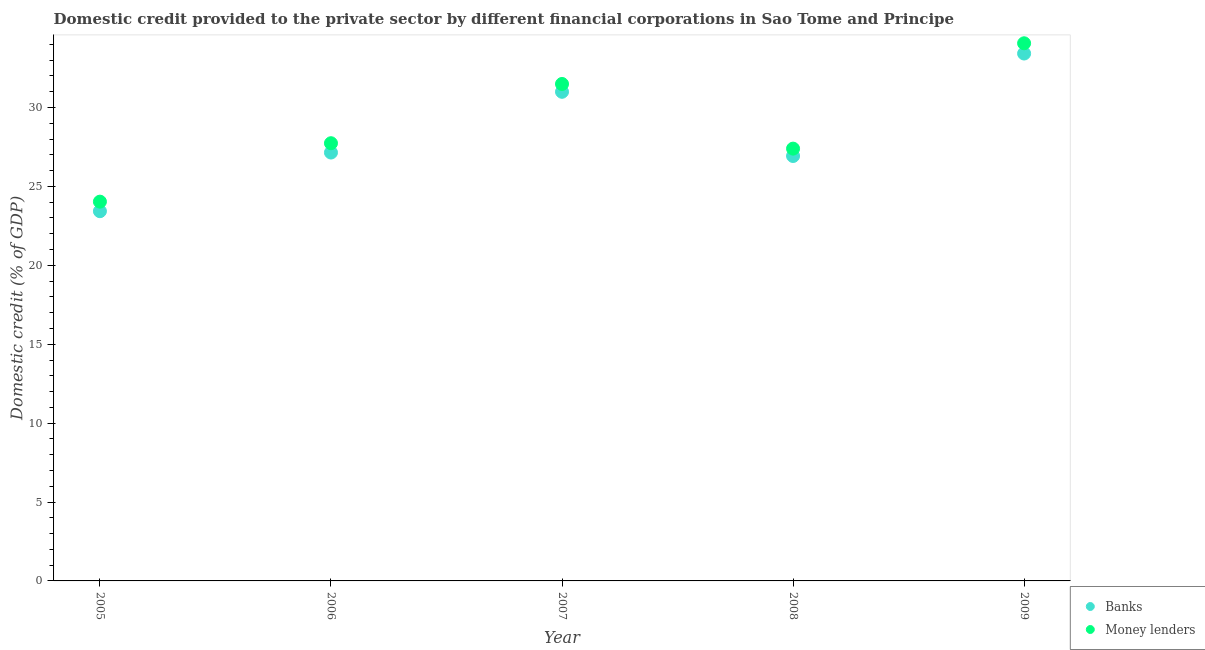How many different coloured dotlines are there?
Provide a short and direct response. 2. Is the number of dotlines equal to the number of legend labels?
Your response must be concise. Yes. What is the domestic credit provided by banks in 2008?
Your answer should be compact. 26.93. Across all years, what is the maximum domestic credit provided by banks?
Give a very brief answer. 33.42. Across all years, what is the minimum domestic credit provided by banks?
Your answer should be very brief. 23.43. What is the total domestic credit provided by banks in the graph?
Your response must be concise. 141.93. What is the difference between the domestic credit provided by money lenders in 2005 and that in 2007?
Provide a succinct answer. -7.46. What is the difference between the domestic credit provided by banks in 2007 and the domestic credit provided by money lenders in 2005?
Offer a very short reply. 6.96. What is the average domestic credit provided by banks per year?
Your response must be concise. 28.39. In the year 2006, what is the difference between the domestic credit provided by banks and domestic credit provided by money lenders?
Your answer should be compact. -0.59. What is the ratio of the domestic credit provided by banks in 2005 to that in 2007?
Your answer should be compact. 0.76. Is the domestic credit provided by money lenders in 2006 less than that in 2008?
Your response must be concise. No. What is the difference between the highest and the second highest domestic credit provided by banks?
Give a very brief answer. 2.43. What is the difference between the highest and the lowest domestic credit provided by banks?
Provide a short and direct response. 9.99. In how many years, is the domestic credit provided by money lenders greater than the average domestic credit provided by money lenders taken over all years?
Give a very brief answer. 2. Does the domestic credit provided by banks monotonically increase over the years?
Keep it short and to the point. No. What is the difference between two consecutive major ticks on the Y-axis?
Offer a very short reply. 5. Are the values on the major ticks of Y-axis written in scientific E-notation?
Your answer should be very brief. No. Does the graph contain grids?
Give a very brief answer. No. How many legend labels are there?
Provide a succinct answer. 2. What is the title of the graph?
Your answer should be compact. Domestic credit provided to the private sector by different financial corporations in Sao Tome and Principe. Does "Central government" appear as one of the legend labels in the graph?
Keep it short and to the point. No. What is the label or title of the X-axis?
Provide a short and direct response. Year. What is the label or title of the Y-axis?
Offer a terse response. Domestic credit (% of GDP). What is the Domestic credit (% of GDP) in Banks in 2005?
Make the answer very short. 23.43. What is the Domestic credit (% of GDP) in Money lenders in 2005?
Your response must be concise. 24.04. What is the Domestic credit (% of GDP) of Banks in 2006?
Your answer should be compact. 27.15. What is the Domestic credit (% of GDP) of Money lenders in 2006?
Make the answer very short. 27.74. What is the Domestic credit (% of GDP) in Banks in 2007?
Keep it short and to the point. 31. What is the Domestic credit (% of GDP) in Money lenders in 2007?
Provide a succinct answer. 31.49. What is the Domestic credit (% of GDP) in Banks in 2008?
Offer a very short reply. 26.93. What is the Domestic credit (% of GDP) in Money lenders in 2008?
Provide a succinct answer. 27.4. What is the Domestic credit (% of GDP) of Banks in 2009?
Your answer should be very brief. 33.42. What is the Domestic credit (% of GDP) in Money lenders in 2009?
Ensure brevity in your answer.  34.07. Across all years, what is the maximum Domestic credit (% of GDP) of Banks?
Your answer should be compact. 33.42. Across all years, what is the maximum Domestic credit (% of GDP) in Money lenders?
Make the answer very short. 34.07. Across all years, what is the minimum Domestic credit (% of GDP) of Banks?
Keep it short and to the point. 23.43. Across all years, what is the minimum Domestic credit (% of GDP) of Money lenders?
Give a very brief answer. 24.04. What is the total Domestic credit (% of GDP) of Banks in the graph?
Offer a very short reply. 141.93. What is the total Domestic credit (% of GDP) of Money lenders in the graph?
Provide a succinct answer. 144.74. What is the difference between the Domestic credit (% of GDP) of Banks in 2005 and that in 2006?
Provide a succinct answer. -3.72. What is the difference between the Domestic credit (% of GDP) in Money lenders in 2005 and that in 2006?
Provide a short and direct response. -3.7. What is the difference between the Domestic credit (% of GDP) in Banks in 2005 and that in 2007?
Provide a succinct answer. -7.57. What is the difference between the Domestic credit (% of GDP) of Money lenders in 2005 and that in 2007?
Offer a very short reply. -7.46. What is the difference between the Domestic credit (% of GDP) in Banks in 2005 and that in 2008?
Keep it short and to the point. -3.5. What is the difference between the Domestic credit (% of GDP) of Money lenders in 2005 and that in 2008?
Ensure brevity in your answer.  -3.36. What is the difference between the Domestic credit (% of GDP) of Banks in 2005 and that in 2009?
Your answer should be compact. -9.99. What is the difference between the Domestic credit (% of GDP) in Money lenders in 2005 and that in 2009?
Give a very brief answer. -10.04. What is the difference between the Domestic credit (% of GDP) of Banks in 2006 and that in 2007?
Your answer should be compact. -3.85. What is the difference between the Domestic credit (% of GDP) of Money lenders in 2006 and that in 2007?
Offer a very short reply. -3.75. What is the difference between the Domestic credit (% of GDP) of Banks in 2006 and that in 2008?
Your answer should be compact. 0.22. What is the difference between the Domestic credit (% of GDP) in Money lenders in 2006 and that in 2008?
Make the answer very short. 0.34. What is the difference between the Domestic credit (% of GDP) in Banks in 2006 and that in 2009?
Make the answer very short. -6.27. What is the difference between the Domestic credit (% of GDP) in Money lenders in 2006 and that in 2009?
Provide a short and direct response. -6.33. What is the difference between the Domestic credit (% of GDP) in Banks in 2007 and that in 2008?
Provide a succinct answer. 4.07. What is the difference between the Domestic credit (% of GDP) in Money lenders in 2007 and that in 2008?
Offer a terse response. 4.1. What is the difference between the Domestic credit (% of GDP) of Banks in 2007 and that in 2009?
Ensure brevity in your answer.  -2.43. What is the difference between the Domestic credit (% of GDP) in Money lenders in 2007 and that in 2009?
Your answer should be compact. -2.58. What is the difference between the Domestic credit (% of GDP) in Banks in 2008 and that in 2009?
Offer a very short reply. -6.49. What is the difference between the Domestic credit (% of GDP) of Money lenders in 2008 and that in 2009?
Your response must be concise. -6.68. What is the difference between the Domestic credit (% of GDP) of Banks in 2005 and the Domestic credit (% of GDP) of Money lenders in 2006?
Keep it short and to the point. -4.31. What is the difference between the Domestic credit (% of GDP) of Banks in 2005 and the Domestic credit (% of GDP) of Money lenders in 2007?
Provide a succinct answer. -8.06. What is the difference between the Domestic credit (% of GDP) in Banks in 2005 and the Domestic credit (% of GDP) in Money lenders in 2008?
Keep it short and to the point. -3.97. What is the difference between the Domestic credit (% of GDP) of Banks in 2005 and the Domestic credit (% of GDP) of Money lenders in 2009?
Ensure brevity in your answer.  -10.64. What is the difference between the Domestic credit (% of GDP) of Banks in 2006 and the Domestic credit (% of GDP) of Money lenders in 2007?
Provide a succinct answer. -4.35. What is the difference between the Domestic credit (% of GDP) in Banks in 2006 and the Domestic credit (% of GDP) in Money lenders in 2008?
Keep it short and to the point. -0.25. What is the difference between the Domestic credit (% of GDP) of Banks in 2006 and the Domestic credit (% of GDP) of Money lenders in 2009?
Offer a very short reply. -6.92. What is the difference between the Domestic credit (% of GDP) in Banks in 2007 and the Domestic credit (% of GDP) in Money lenders in 2008?
Give a very brief answer. 3.6. What is the difference between the Domestic credit (% of GDP) of Banks in 2007 and the Domestic credit (% of GDP) of Money lenders in 2009?
Provide a succinct answer. -3.08. What is the difference between the Domestic credit (% of GDP) of Banks in 2008 and the Domestic credit (% of GDP) of Money lenders in 2009?
Ensure brevity in your answer.  -7.14. What is the average Domestic credit (% of GDP) of Banks per year?
Provide a short and direct response. 28.39. What is the average Domestic credit (% of GDP) in Money lenders per year?
Offer a very short reply. 28.95. In the year 2005, what is the difference between the Domestic credit (% of GDP) of Banks and Domestic credit (% of GDP) of Money lenders?
Your response must be concise. -0.6. In the year 2006, what is the difference between the Domestic credit (% of GDP) in Banks and Domestic credit (% of GDP) in Money lenders?
Offer a very short reply. -0.59. In the year 2007, what is the difference between the Domestic credit (% of GDP) in Banks and Domestic credit (% of GDP) in Money lenders?
Your answer should be very brief. -0.5. In the year 2008, what is the difference between the Domestic credit (% of GDP) in Banks and Domestic credit (% of GDP) in Money lenders?
Your response must be concise. -0.47. In the year 2009, what is the difference between the Domestic credit (% of GDP) in Banks and Domestic credit (% of GDP) in Money lenders?
Offer a very short reply. -0.65. What is the ratio of the Domestic credit (% of GDP) in Banks in 2005 to that in 2006?
Make the answer very short. 0.86. What is the ratio of the Domestic credit (% of GDP) of Money lenders in 2005 to that in 2006?
Ensure brevity in your answer.  0.87. What is the ratio of the Domestic credit (% of GDP) in Banks in 2005 to that in 2007?
Offer a very short reply. 0.76. What is the ratio of the Domestic credit (% of GDP) of Money lenders in 2005 to that in 2007?
Your response must be concise. 0.76. What is the ratio of the Domestic credit (% of GDP) in Banks in 2005 to that in 2008?
Your response must be concise. 0.87. What is the ratio of the Domestic credit (% of GDP) of Money lenders in 2005 to that in 2008?
Give a very brief answer. 0.88. What is the ratio of the Domestic credit (% of GDP) of Banks in 2005 to that in 2009?
Your answer should be compact. 0.7. What is the ratio of the Domestic credit (% of GDP) in Money lenders in 2005 to that in 2009?
Provide a short and direct response. 0.71. What is the ratio of the Domestic credit (% of GDP) of Banks in 2006 to that in 2007?
Make the answer very short. 0.88. What is the ratio of the Domestic credit (% of GDP) in Money lenders in 2006 to that in 2007?
Your answer should be very brief. 0.88. What is the ratio of the Domestic credit (% of GDP) of Money lenders in 2006 to that in 2008?
Give a very brief answer. 1.01. What is the ratio of the Domestic credit (% of GDP) in Banks in 2006 to that in 2009?
Keep it short and to the point. 0.81. What is the ratio of the Domestic credit (% of GDP) in Money lenders in 2006 to that in 2009?
Make the answer very short. 0.81. What is the ratio of the Domestic credit (% of GDP) of Banks in 2007 to that in 2008?
Your answer should be compact. 1.15. What is the ratio of the Domestic credit (% of GDP) in Money lenders in 2007 to that in 2008?
Your answer should be very brief. 1.15. What is the ratio of the Domestic credit (% of GDP) in Banks in 2007 to that in 2009?
Provide a short and direct response. 0.93. What is the ratio of the Domestic credit (% of GDP) of Money lenders in 2007 to that in 2009?
Offer a very short reply. 0.92. What is the ratio of the Domestic credit (% of GDP) in Banks in 2008 to that in 2009?
Offer a very short reply. 0.81. What is the ratio of the Domestic credit (% of GDP) of Money lenders in 2008 to that in 2009?
Offer a very short reply. 0.8. What is the difference between the highest and the second highest Domestic credit (% of GDP) in Banks?
Provide a succinct answer. 2.43. What is the difference between the highest and the second highest Domestic credit (% of GDP) of Money lenders?
Your answer should be compact. 2.58. What is the difference between the highest and the lowest Domestic credit (% of GDP) of Banks?
Offer a terse response. 9.99. What is the difference between the highest and the lowest Domestic credit (% of GDP) in Money lenders?
Provide a succinct answer. 10.04. 